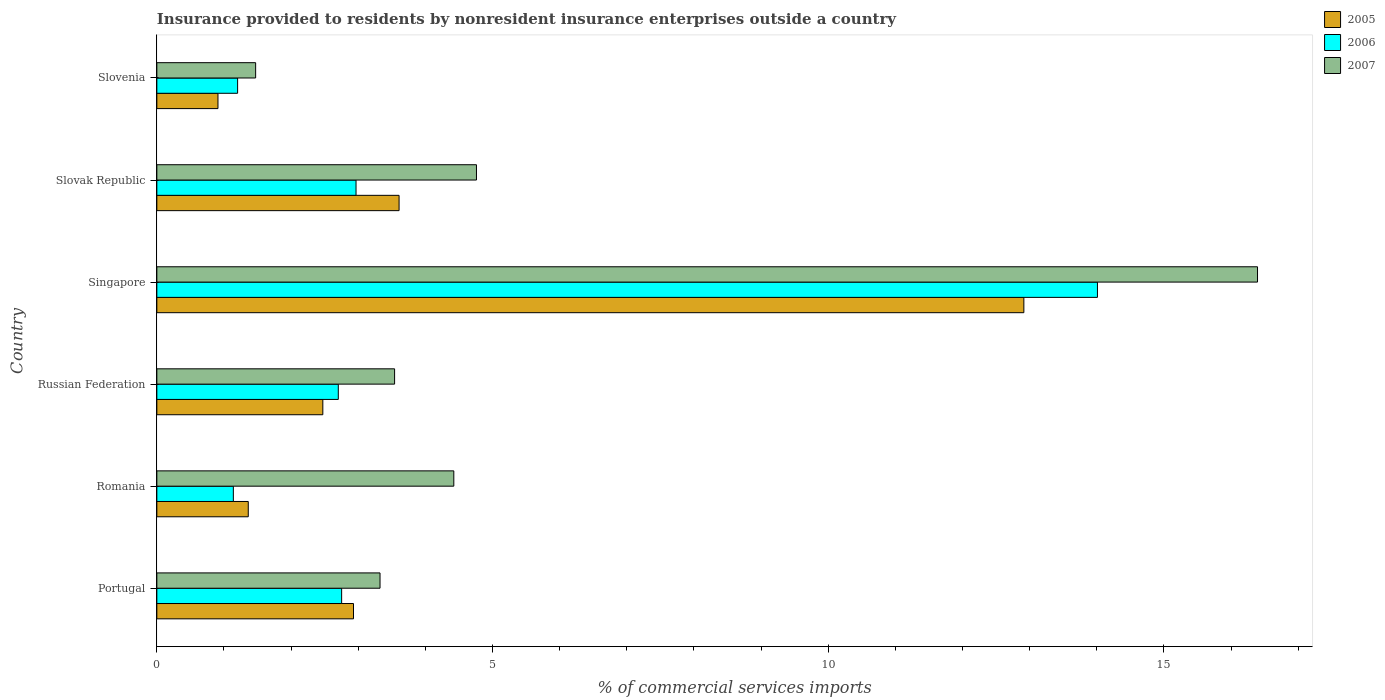How many different coloured bars are there?
Provide a short and direct response. 3. Are the number of bars per tick equal to the number of legend labels?
Provide a succinct answer. Yes. How many bars are there on the 1st tick from the top?
Make the answer very short. 3. How many bars are there on the 5th tick from the bottom?
Offer a terse response. 3. In how many cases, is the number of bars for a given country not equal to the number of legend labels?
Your answer should be compact. 0. What is the Insurance provided to residents in 2005 in Slovak Republic?
Make the answer very short. 3.61. Across all countries, what is the maximum Insurance provided to residents in 2005?
Your answer should be very brief. 12.91. Across all countries, what is the minimum Insurance provided to residents in 2005?
Provide a short and direct response. 0.91. In which country was the Insurance provided to residents in 2005 maximum?
Your answer should be compact. Singapore. In which country was the Insurance provided to residents in 2006 minimum?
Provide a short and direct response. Romania. What is the total Insurance provided to residents in 2005 in the graph?
Your response must be concise. 24.19. What is the difference between the Insurance provided to residents in 2006 in Portugal and that in Slovenia?
Keep it short and to the point. 1.55. What is the difference between the Insurance provided to residents in 2006 in Russian Federation and the Insurance provided to residents in 2007 in Singapore?
Offer a very short reply. -13.69. What is the average Insurance provided to residents in 2006 per country?
Offer a terse response. 4.13. What is the difference between the Insurance provided to residents in 2006 and Insurance provided to residents in 2007 in Portugal?
Offer a terse response. -0.57. In how many countries, is the Insurance provided to residents in 2007 greater than 14 %?
Your answer should be compact. 1. What is the ratio of the Insurance provided to residents in 2005 in Romania to that in Slovenia?
Your answer should be compact. 1.5. Is the Insurance provided to residents in 2006 in Slovak Republic less than that in Slovenia?
Your response must be concise. No. What is the difference between the highest and the second highest Insurance provided to residents in 2006?
Provide a short and direct response. 11.04. What is the difference between the highest and the lowest Insurance provided to residents in 2006?
Your answer should be very brief. 12.87. Is the sum of the Insurance provided to residents in 2007 in Russian Federation and Slovenia greater than the maximum Insurance provided to residents in 2005 across all countries?
Ensure brevity in your answer.  No. What does the 3rd bar from the top in Slovenia represents?
Provide a short and direct response. 2005. What does the 3rd bar from the bottom in Slovenia represents?
Ensure brevity in your answer.  2007. Is it the case that in every country, the sum of the Insurance provided to residents in 2005 and Insurance provided to residents in 2007 is greater than the Insurance provided to residents in 2006?
Offer a terse response. Yes. How many bars are there?
Your answer should be compact. 18. What is the difference between two consecutive major ticks on the X-axis?
Give a very brief answer. 5. Are the values on the major ticks of X-axis written in scientific E-notation?
Offer a terse response. No. Does the graph contain any zero values?
Your answer should be very brief. No. Does the graph contain grids?
Offer a terse response. No. What is the title of the graph?
Keep it short and to the point. Insurance provided to residents by nonresident insurance enterprises outside a country. Does "2013" appear as one of the legend labels in the graph?
Make the answer very short. No. What is the label or title of the X-axis?
Your response must be concise. % of commercial services imports. What is the label or title of the Y-axis?
Give a very brief answer. Country. What is the % of commercial services imports of 2005 in Portugal?
Your answer should be compact. 2.93. What is the % of commercial services imports in 2006 in Portugal?
Make the answer very short. 2.75. What is the % of commercial services imports of 2007 in Portugal?
Your answer should be very brief. 3.32. What is the % of commercial services imports of 2005 in Romania?
Your answer should be very brief. 1.36. What is the % of commercial services imports of 2006 in Romania?
Your response must be concise. 1.14. What is the % of commercial services imports of 2007 in Romania?
Your response must be concise. 4.42. What is the % of commercial services imports in 2005 in Russian Federation?
Provide a succinct answer. 2.47. What is the % of commercial services imports of 2006 in Russian Federation?
Offer a very short reply. 2.7. What is the % of commercial services imports in 2007 in Russian Federation?
Ensure brevity in your answer.  3.54. What is the % of commercial services imports of 2005 in Singapore?
Offer a terse response. 12.91. What is the % of commercial services imports in 2006 in Singapore?
Your answer should be very brief. 14.01. What is the % of commercial services imports in 2007 in Singapore?
Offer a very short reply. 16.39. What is the % of commercial services imports in 2005 in Slovak Republic?
Offer a terse response. 3.61. What is the % of commercial services imports in 2006 in Slovak Republic?
Provide a succinct answer. 2.97. What is the % of commercial services imports in 2007 in Slovak Republic?
Keep it short and to the point. 4.76. What is the % of commercial services imports in 2005 in Slovenia?
Your response must be concise. 0.91. What is the % of commercial services imports of 2006 in Slovenia?
Offer a very short reply. 1.2. What is the % of commercial services imports in 2007 in Slovenia?
Ensure brevity in your answer.  1.47. Across all countries, what is the maximum % of commercial services imports of 2005?
Provide a succinct answer. 12.91. Across all countries, what is the maximum % of commercial services imports in 2006?
Provide a succinct answer. 14.01. Across all countries, what is the maximum % of commercial services imports of 2007?
Provide a succinct answer. 16.39. Across all countries, what is the minimum % of commercial services imports of 2005?
Offer a terse response. 0.91. Across all countries, what is the minimum % of commercial services imports in 2006?
Keep it short and to the point. 1.14. Across all countries, what is the minimum % of commercial services imports of 2007?
Provide a short and direct response. 1.47. What is the total % of commercial services imports in 2005 in the graph?
Provide a succinct answer. 24.19. What is the total % of commercial services imports in 2006 in the graph?
Your answer should be compact. 24.77. What is the total % of commercial services imports of 2007 in the graph?
Ensure brevity in your answer.  33.91. What is the difference between the % of commercial services imports of 2005 in Portugal and that in Romania?
Your answer should be compact. 1.57. What is the difference between the % of commercial services imports of 2006 in Portugal and that in Romania?
Provide a short and direct response. 1.61. What is the difference between the % of commercial services imports of 2007 in Portugal and that in Romania?
Your answer should be very brief. -1.1. What is the difference between the % of commercial services imports of 2005 in Portugal and that in Russian Federation?
Offer a very short reply. 0.46. What is the difference between the % of commercial services imports in 2006 in Portugal and that in Russian Federation?
Offer a terse response. 0.05. What is the difference between the % of commercial services imports in 2007 in Portugal and that in Russian Federation?
Your answer should be compact. -0.22. What is the difference between the % of commercial services imports in 2005 in Portugal and that in Singapore?
Make the answer very short. -9.98. What is the difference between the % of commercial services imports of 2006 in Portugal and that in Singapore?
Ensure brevity in your answer.  -11.26. What is the difference between the % of commercial services imports in 2007 in Portugal and that in Singapore?
Provide a short and direct response. -13.07. What is the difference between the % of commercial services imports of 2005 in Portugal and that in Slovak Republic?
Ensure brevity in your answer.  -0.68. What is the difference between the % of commercial services imports of 2006 in Portugal and that in Slovak Republic?
Provide a succinct answer. -0.21. What is the difference between the % of commercial services imports of 2007 in Portugal and that in Slovak Republic?
Give a very brief answer. -1.44. What is the difference between the % of commercial services imports in 2005 in Portugal and that in Slovenia?
Provide a short and direct response. 2.02. What is the difference between the % of commercial services imports of 2006 in Portugal and that in Slovenia?
Give a very brief answer. 1.55. What is the difference between the % of commercial services imports of 2007 in Portugal and that in Slovenia?
Offer a very short reply. 1.85. What is the difference between the % of commercial services imports of 2005 in Romania and that in Russian Federation?
Keep it short and to the point. -1.11. What is the difference between the % of commercial services imports of 2006 in Romania and that in Russian Federation?
Your answer should be compact. -1.56. What is the difference between the % of commercial services imports in 2007 in Romania and that in Russian Federation?
Give a very brief answer. 0.88. What is the difference between the % of commercial services imports in 2005 in Romania and that in Singapore?
Your answer should be very brief. -11.55. What is the difference between the % of commercial services imports in 2006 in Romania and that in Singapore?
Provide a succinct answer. -12.87. What is the difference between the % of commercial services imports in 2007 in Romania and that in Singapore?
Offer a terse response. -11.97. What is the difference between the % of commercial services imports in 2005 in Romania and that in Slovak Republic?
Make the answer very short. -2.25. What is the difference between the % of commercial services imports of 2006 in Romania and that in Slovak Republic?
Give a very brief answer. -1.83. What is the difference between the % of commercial services imports of 2007 in Romania and that in Slovak Republic?
Ensure brevity in your answer.  -0.34. What is the difference between the % of commercial services imports in 2005 in Romania and that in Slovenia?
Offer a very short reply. 0.45. What is the difference between the % of commercial services imports in 2006 in Romania and that in Slovenia?
Offer a terse response. -0.06. What is the difference between the % of commercial services imports of 2007 in Romania and that in Slovenia?
Make the answer very short. 2.95. What is the difference between the % of commercial services imports in 2005 in Russian Federation and that in Singapore?
Offer a very short reply. -10.44. What is the difference between the % of commercial services imports in 2006 in Russian Federation and that in Singapore?
Give a very brief answer. -11.31. What is the difference between the % of commercial services imports in 2007 in Russian Federation and that in Singapore?
Provide a succinct answer. -12.85. What is the difference between the % of commercial services imports of 2005 in Russian Federation and that in Slovak Republic?
Offer a very short reply. -1.14. What is the difference between the % of commercial services imports in 2006 in Russian Federation and that in Slovak Republic?
Offer a very short reply. -0.26. What is the difference between the % of commercial services imports of 2007 in Russian Federation and that in Slovak Republic?
Offer a terse response. -1.22. What is the difference between the % of commercial services imports in 2005 in Russian Federation and that in Slovenia?
Ensure brevity in your answer.  1.56. What is the difference between the % of commercial services imports in 2006 in Russian Federation and that in Slovenia?
Your response must be concise. 1.5. What is the difference between the % of commercial services imports in 2007 in Russian Federation and that in Slovenia?
Your answer should be very brief. 2.07. What is the difference between the % of commercial services imports in 2005 in Singapore and that in Slovak Republic?
Provide a succinct answer. 9.31. What is the difference between the % of commercial services imports of 2006 in Singapore and that in Slovak Republic?
Your answer should be very brief. 11.04. What is the difference between the % of commercial services imports of 2007 in Singapore and that in Slovak Republic?
Make the answer very short. 11.63. What is the difference between the % of commercial services imports of 2005 in Singapore and that in Slovenia?
Your answer should be compact. 12. What is the difference between the % of commercial services imports in 2006 in Singapore and that in Slovenia?
Your answer should be very brief. 12.81. What is the difference between the % of commercial services imports of 2007 in Singapore and that in Slovenia?
Make the answer very short. 14.92. What is the difference between the % of commercial services imports in 2005 in Slovak Republic and that in Slovenia?
Provide a short and direct response. 2.7. What is the difference between the % of commercial services imports of 2006 in Slovak Republic and that in Slovenia?
Offer a very short reply. 1.76. What is the difference between the % of commercial services imports in 2007 in Slovak Republic and that in Slovenia?
Your answer should be compact. 3.29. What is the difference between the % of commercial services imports in 2005 in Portugal and the % of commercial services imports in 2006 in Romania?
Give a very brief answer. 1.79. What is the difference between the % of commercial services imports in 2005 in Portugal and the % of commercial services imports in 2007 in Romania?
Make the answer very short. -1.49. What is the difference between the % of commercial services imports of 2006 in Portugal and the % of commercial services imports of 2007 in Romania?
Your response must be concise. -1.67. What is the difference between the % of commercial services imports in 2005 in Portugal and the % of commercial services imports in 2006 in Russian Federation?
Give a very brief answer. 0.23. What is the difference between the % of commercial services imports in 2005 in Portugal and the % of commercial services imports in 2007 in Russian Federation?
Your response must be concise. -0.61. What is the difference between the % of commercial services imports of 2006 in Portugal and the % of commercial services imports of 2007 in Russian Federation?
Keep it short and to the point. -0.79. What is the difference between the % of commercial services imports in 2005 in Portugal and the % of commercial services imports in 2006 in Singapore?
Ensure brevity in your answer.  -11.08. What is the difference between the % of commercial services imports in 2005 in Portugal and the % of commercial services imports in 2007 in Singapore?
Offer a very short reply. -13.46. What is the difference between the % of commercial services imports of 2006 in Portugal and the % of commercial services imports of 2007 in Singapore?
Provide a short and direct response. -13.64. What is the difference between the % of commercial services imports in 2005 in Portugal and the % of commercial services imports in 2006 in Slovak Republic?
Your answer should be very brief. -0.04. What is the difference between the % of commercial services imports in 2005 in Portugal and the % of commercial services imports in 2007 in Slovak Republic?
Make the answer very short. -1.83. What is the difference between the % of commercial services imports in 2006 in Portugal and the % of commercial services imports in 2007 in Slovak Republic?
Ensure brevity in your answer.  -2.01. What is the difference between the % of commercial services imports in 2005 in Portugal and the % of commercial services imports in 2006 in Slovenia?
Keep it short and to the point. 1.73. What is the difference between the % of commercial services imports of 2005 in Portugal and the % of commercial services imports of 2007 in Slovenia?
Provide a succinct answer. 1.46. What is the difference between the % of commercial services imports of 2006 in Portugal and the % of commercial services imports of 2007 in Slovenia?
Your answer should be very brief. 1.28. What is the difference between the % of commercial services imports of 2005 in Romania and the % of commercial services imports of 2006 in Russian Federation?
Offer a very short reply. -1.34. What is the difference between the % of commercial services imports of 2005 in Romania and the % of commercial services imports of 2007 in Russian Federation?
Give a very brief answer. -2.18. What is the difference between the % of commercial services imports of 2006 in Romania and the % of commercial services imports of 2007 in Russian Federation?
Your answer should be compact. -2.4. What is the difference between the % of commercial services imports of 2005 in Romania and the % of commercial services imports of 2006 in Singapore?
Offer a terse response. -12.65. What is the difference between the % of commercial services imports in 2005 in Romania and the % of commercial services imports in 2007 in Singapore?
Make the answer very short. -15.03. What is the difference between the % of commercial services imports in 2006 in Romania and the % of commercial services imports in 2007 in Singapore?
Provide a succinct answer. -15.25. What is the difference between the % of commercial services imports of 2005 in Romania and the % of commercial services imports of 2006 in Slovak Republic?
Ensure brevity in your answer.  -1.61. What is the difference between the % of commercial services imports of 2005 in Romania and the % of commercial services imports of 2007 in Slovak Republic?
Make the answer very short. -3.4. What is the difference between the % of commercial services imports in 2006 in Romania and the % of commercial services imports in 2007 in Slovak Republic?
Your answer should be very brief. -3.62. What is the difference between the % of commercial services imports in 2005 in Romania and the % of commercial services imports in 2006 in Slovenia?
Ensure brevity in your answer.  0.16. What is the difference between the % of commercial services imports in 2005 in Romania and the % of commercial services imports in 2007 in Slovenia?
Give a very brief answer. -0.11. What is the difference between the % of commercial services imports in 2006 in Romania and the % of commercial services imports in 2007 in Slovenia?
Offer a terse response. -0.33. What is the difference between the % of commercial services imports in 2005 in Russian Federation and the % of commercial services imports in 2006 in Singapore?
Your answer should be very brief. -11.54. What is the difference between the % of commercial services imports in 2005 in Russian Federation and the % of commercial services imports in 2007 in Singapore?
Your answer should be compact. -13.92. What is the difference between the % of commercial services imports of 2006 in Russian Federation and the % of commercial services imports of 2007 in Singapore?
Offer a terse response. -13.69. What is the difference between the % of commercial services imports in 2005 in Russian Federation and the % of commercial services imports in 2006 in Slovak Republic?
Make the answer very short. -0.49. What is the difference between the % of commercial services imports in 2005 in Russian Federation and the % of commercial services imports in 2007 in Slovak Republic?
Ensure brevity in your answer.  -2.29. What is the difference between the % of commercial services imports in 2006 in Russian Federation and the % of commercial services imports in 2007 in Slovak Republic?
Give a very brief answer. -2.06. What is the difference between the % of commercial services imports in 2005 in Russian Federation and the % of commercial services imports in 2006 in Slovenia?
Your answer should be compact. 1.27. What is the difference between the % of commercial services imports of 2005 in Russian Federation and the % of commercial services imports of 2007 in Slovenia?
Provide a succinct answer. 1. What is the difference between the % of commercial services imports in 2006 in Russian Federation and the % of commercial services imports in 2007 in Slovenia?
Your answer should be very brief. 1.23. What is the difference between the % of commercial services imports in 2005 in Singapore and the % of commercial services imports in 2006 in Slovak Republic?
Your response must be concise. 9.95. What is the difference between the % of commercial services imports in 2005 in Singapore and the % of commercial services imports in 2007 in Slovak Republic?
Ensure brevity in your answer.  8.15. What is the difference between the % of commercial services imports in 2006 in Singapore and the % of commercial services imports in 2007 in Slovak Republic?
Provide a short and direct response. 9.25. What is the difference between the % of commercial services imports in 2005 in Singapore and the % of commercial services imports in 2006 in Slovenia?
Your response must be concise. 11.71. What is the difference between the % of commercial services imports in 2005 in Singapore and the % of commercial services imports in 2007 in Slovenia?
Your response must be concise. 11.44. What is the difference between the % of commercial services imports of 2006 in Singapore and the % of commercial services imports of 2007 in Slovenia?
Provide a succinct answer. 12.54. What is the difference between the % of commercial services imports of 2005 in Slovak Republic and the % of commercial services imports of 2006 in Slovenia?
Your response must be concise. 2.4. What is the difference between the % of commercial services imports of 2005 in Slovak Republic and the % of commercial services imports of 2007 in Slovenia?
Your answer should be very brief. 2.14. What is the difference between the % of commercial services imports of 2006 in Slovak Republic and the % of commercial services imports of 2007 in Slovenia?
Offer a terse response. 1.5. What is the average % of commercial services imports in 2005 per country?
Offer a terse response. 4.03. What is the average % of commercial services imports in 2006 per country?
Your answer should be compact. 4.13. What is the average % of commercial services imports in 2007 per country?
Your answer should be compact. 5.65. What is the difference between the % of commercial services imports in 2005 and % of commercial services imports in 2006 in Portugal?
Make the answer very short. 0.18. What is the difference between the % of commercial services imports in 2005 and % of commercial services imports in 2007 in Portugal?
Your answer should be very brief. -0.4. What is the difference between the % of commercial services imports of 2006 and % of commercial services imports of 2007 in Portugal?
Provide a short and direct response. -0.57. What is the difference between the % of commercial services imports in 2005 and % of commercial services imports in 2006 in Romania?
Make the answer very short. 0.22. What is the difference between the % of commercial services imports of 2005 and % of commercial services imports of 2007 in Romania?
Offer a very short reply. -3.06. What is the difference between the % of commercial services imports of 2006 and % of commercial services imports of 2007 in Romania?
Keep it short and to the point. -3.28. What is the difference between the % of commercial services imports of 2005 and % of commercial services imports of 2006 in Russian Federation?
Give a very brief answer. -0.23. What is the difference between the % of commercial services imports in 2005 and % of commercial services imports in 2007 in Russian Federation?
Provide a short and direct response. -1.07. What is the difference between the % of commercial services imports in 2006 and % of commercial services imports in 2007 in Russian Federation?
Provide a succinct answer. -0.84. What is the difference between the % of commercial services imports in 2005 and % of commercial services imports in 2006 in Singapore?
Make the answer very short. -1.1. What is the difference between the % of commercial services imports in 2005 and % of commercial services imports in 2007 in Singapore?
Provide a short and direct response. -3.48. What is the difference between the % of commercial services imports in 2006 and % of commercial services imports in 2007 in Singapore?
Provide a short and direct response. -2.38. What is the difference between the % of commercial services imports of 2005 and % of commercial services imports of 2006 in Slovak Republic?
Keep it short and to the point. 0.64. What is the difference between the % of commercial services imports of 2005 and % of commercial services imports of 2007 in Slovak Republic?
Offer a very short reply. -1.15. What is the difference between the % of commercial services imports of 2006 and % of commercial services imports of 2007 in Slovak Republic?
Make the answer very short. -1.79. What is the difference between the % of commercial services imports of 2005 and % of commercial services imports of 2006 in Slovenia?
Your response must be concise. -0.29. What is the difference between the % of commercial services imports in 2005 and % of commercial services imports in 2007 in Slovenia?
Make the answer very short. -0.56. What is the difference between the % of commercial services imports of 2006 and % of commercial services imports of 2007 in Slovenia?
Make the answer very short. -0.27. What is the ratio of the % of commercial services imports of 2005 in Portugal to that in Romania?
Give a very brief answer. 2.15. What is the ratio of the % of commercial services imports of 2006 in Portugal to that in Romania?
Provide a succinct answer. 2.42. What is the ratio of the % of commercial services imports of 2007 in Portugal to that in Romania?
Give a very brief answer. 0.75. What is the ratio of the % of commercial services imports of 2005 in Portugal to that in Russian Federation?
Make the answer very short. 1.18. What is the ratio of the % of commercial services imports of 2006 in Portugal to that in Russian Federation?
Provide a succinct answer. 1.02. What is the ratio of the % of commercial services imports of 2007 in Portugal to that in Russian Federation?
Offer a very short reply. 0.94. What is the ratio of the % of commercial services imports of 2005 in Portugal to that in Singapore?
Offer a very short reply. 0.23. What is the ratio of the % of commercial services imports in 2006 in Portugal to that in Singapore?
Keep it short and to the point. 0.2. What is the ratio of the % of commercial services imports of 2007 in Portugal to that in Singapore?
Your answer should be very brief. 0.2. What is the ratio of the % of commercial services imports in 2005 in Portugal to that in Slovak Republic?
Provide a short and direct response. 0.81. What is the ratio of the % of commercial services imports in 2006 in Portugal to that in Slovak Republic?
Provide a succinct answer. 0.93. What is the ratio of the % of commercial services imports of 2007 in Portugal to that in Slovak Republic?
Provide a succinct answer. 0.7. What is the ratio of the % of commercial services imports in 2005 in Portugal to that in Slovenia?
Offer a very short reply. 3.22. What is the ratio of the % of commercial services imports of 2006 in Portugal to that in Slovenia?
Give a very brief answer. 2.29. What is the ratio of the % of commercial services imports in 2007 in Portugal to that in Slovenia?
Offer a very short reply. 2.26. What is the ratio of the % of commercial services imports of 2005 in Romania to that in Russian Federation?
Give a very brief answer. 0.55. What is the ratio of the % of commercial services imports in 2006 in Romania to that in Russian Federation?
Your response must be concise. 0.42. What is the ratio of the % of commercial services imports of 2007 in Romania to that in Russian Federation?
Give a very brief answer. 1.25. What is the ratio of the % of commercial services imports of 2005 in Romania to that in Singapore?
Offer a terse response. 0.11. What is the ratio of the % of commercial services imports in 2006 in Romania to that in Singapore?
Give a very brief answer. 0.08. What is the ratio of the % of commercial services imports of 2007 in Romania to that in Singapore?
Offer a terse response. 0.27. What is the ratio of the % of commercial services imports in 2005 in Romania to that in Slovak Republic?
Your answer should be compact. 0.38. What is the ratio of the % of commercial services imports of 2006 in Romania to that in Slovak Republic?
Provide a succinct answer. 0.38. What is the ratio of the % of commercial services imports of 2007 in Romania to that in Slovak Republic?
Your response must be concise. 0.93. What is the ratio of the % of commercial services imports of 2005 in Romania to that in Slovenia?
Your response must be concise. 1.5. What is the ratio of the % of commercial services imports in 2006 in Romania to that in Slovenia?
Your answer should be very brief. 0.95. What is the ratio of the % of commercial services imports of 2007 in Romania to that in Slovenia?
Offer a very short reply. 3.01. What is the ratio of the % of commercial services imports of 2005 in Russian Federation to that in Singapore?
Keep it short and to the point. 0.19. What is the ratio of the % of commercial services imports of 2006 in Russian Federation to that in Singapore?
Give a very brief answer. 0.19. What is the ratio of the % of commercial services imports of 2007 in Russian Federation to that in Singapore?
Your response must be concise. 0.22. What is the ratio of the % of commercial services imports in 2005 in Russian Federation to that in Slovak Republic?
Your response must be concise. 0.69. What is the ratio of the % of commercial services imports of 2006 in Russian Federation to that in Slovak Republic?
Make the answer very short. 0.91. What is the ratio of the % of commercial services imports of 2007 in Russian Federation to that in Slovak Republic?
Your answer should be compact. 0.74. What is the ratio of the % of commercial services imports of 2005 in Russian Federation to that in Slovenia?
Make the answer very short. 2.72. What is the ratio of the % of commercial services imports in 2006 in Russian Federation to that in Slovenia?
Your answer should be compact. 2.25. What is the ratio of the % of commercial services imports of 2007 in Russian Federation to that in Slovenia?
Your answer should be very brief. 2.41. What is the ratio of the % of commercial services imports in 2005 in Singapore to that in Slovak Republic?
Ensure brevity in your answer.  3.58. What is the ratio of the % of commercial services imports of 2006 in Singapore to that in Slovak Republic?
Keep it short and to the point. 4.72. What is the ratio of the % of commercial services imports in 2007 in Singapore to that in Slovak Republic?
Provide a succinct answer. 3.44. What is the ratio of the % of commercial services imports of 2005 in Singapore to that in Slovenia?
Keep it short and to the point. 14.18. What is the ratio of the % of commercial services imports of 2006 in Singapore to that in Slovenia?
Provide a short and direct response. 11.65. What is the ratio of the % of commercial services imports in 2007 in Singapore to that in Slovenia?
Your answer should be compact. 11.14. What is the ratio of the % of commercial services imports of 2005 in Slovak Republic to that in Slovenia?
Give a very brief answer. 3.96. What is the ratio of the % of commercial services imports of 2006 in Slovak Republic to that in Slovenia?
Your response must be concise. 2.47. What is the ratio of the % of commercial services imports of 2007 in Slovak Republic to that in Slovenia?
Provide a short and direct response. 3.24. What is the difference between the highest and the second highest % of commercial services imports in 2005?
Provide a short and direct response. 9.31. What is the difference between the highest and the second highest % of commercial services imports in 2006?
Give a very brief answer. 11.04. What is the difference between the highest and the second highest % of commercial services imports in 2007?
Offer a very short reply. 11.63. What is the difference between the highest and the lowest % of commercial services imports in 2005?
Provide a succinct answer. 12. What is the difference between the highest and the lowest % of commercial services imports of 2006?
Your answer should be compact. 12.87. What is the difference between the highest and the lowest % of commercial services imports in 2007?
Your response must be concise. 14.92. 